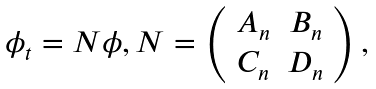Convert formula to latex. <formula><loc_0><loc_0><loc_500><loc_500>\begin{array} { l } \phi _ { t } = N \phi , N = \left ( \begin{array} { c c } A _ { n } & B _ { n } \\ C _ { n } & D _ { n } \end{array} \right ) , \end{array}</formula> 